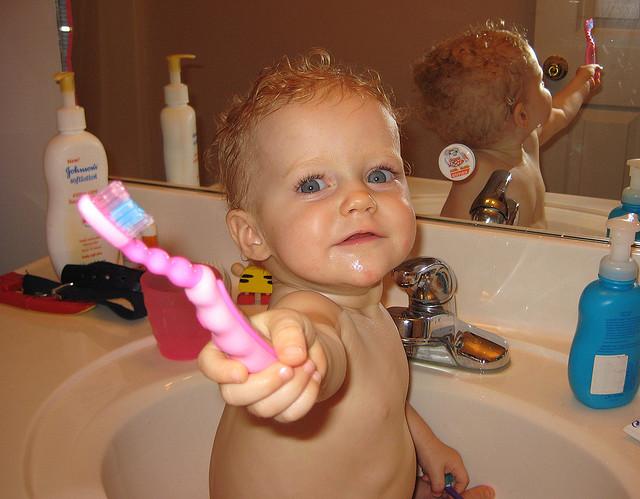What is the baby holding?
Give a very brief answer. Toothbrush. Where is the baby sitting?
Answer briefly. Sink. What color is the baby's hair?
Give a very brief answer. Red. 